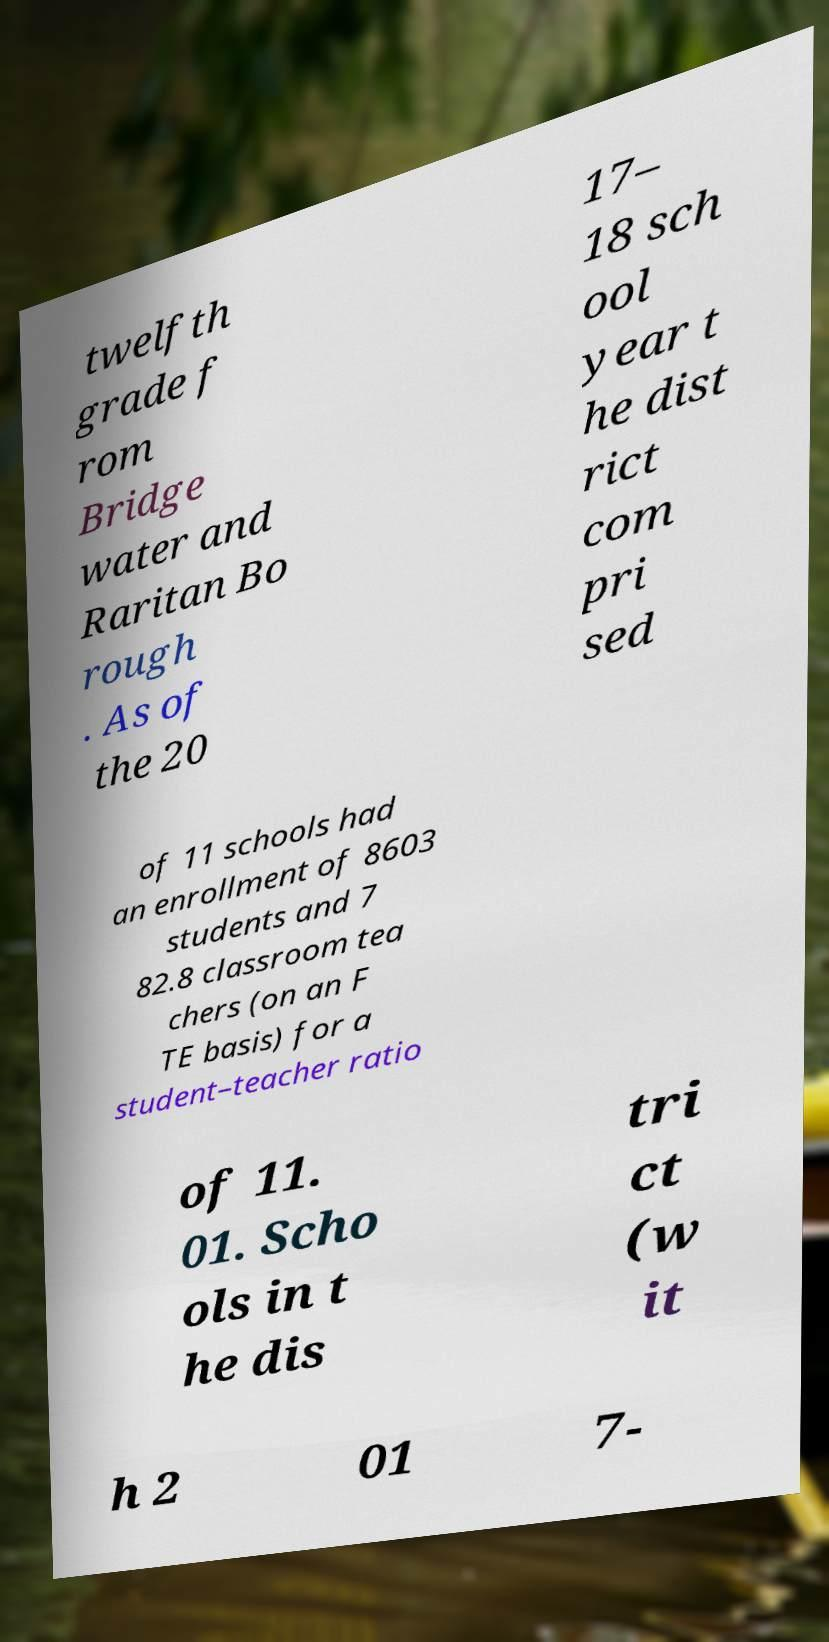For documentation purposes, I need the text within this image transcribed. Could you provide that? twelfth grade f rom Bridge water and Raritan Bo rough . As of the 20 17– 18 sch ool year t he dist rict com pri sed of 11 schools had an enrollment of 8603 students and 7 82.8 classroom tea chers (on an F TE basis) for a student–teacher ratio of 11. 01. Scho ols in t he dis tri ct (w it h 2 01 7- 